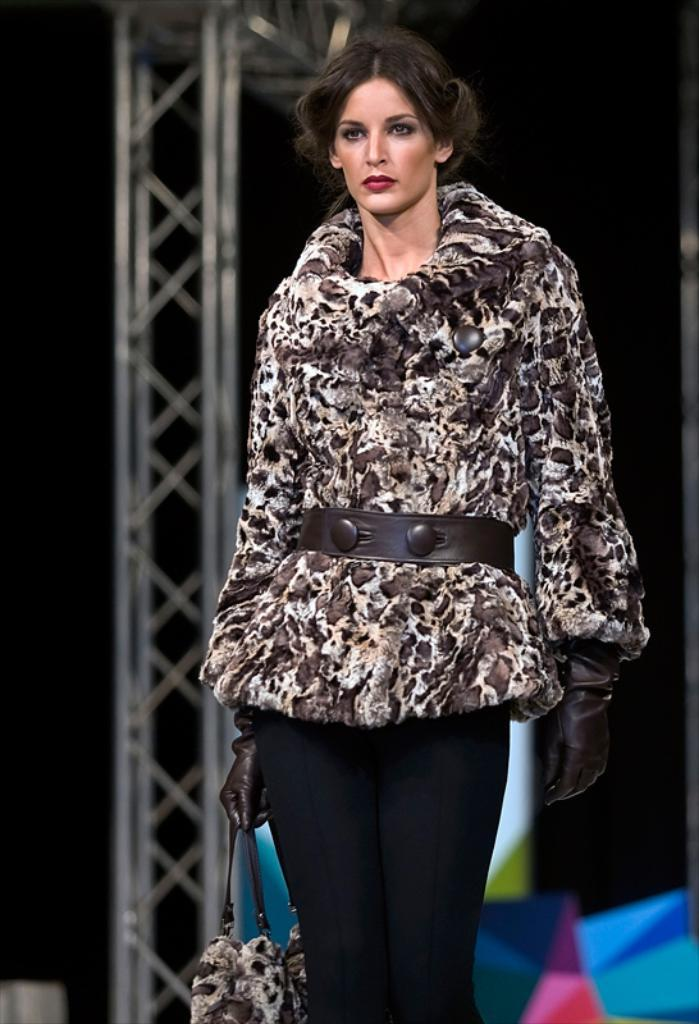Who is present in the image? There is a woman in the image. What is the woman doing in the image? The woman is standing in the image. What is the woman holding in the image? The woman is holding a handbag in the image. What type of clothing is the woman wearing on her hands? The woman is wearing gloves in the image. What word does the woman say in the image? There is no indication of the woman speaking or saying any words in the image. 